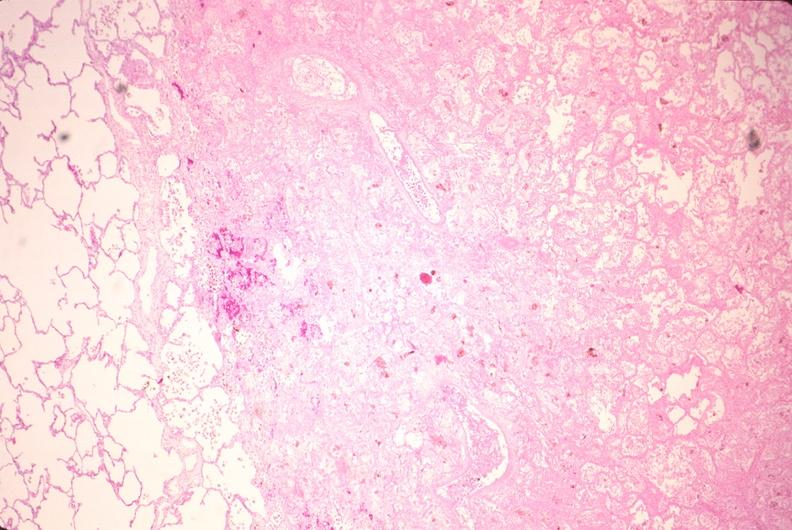does opened muscle show lung, infarct, acute and organized?
Answer the question using a single word or phrase. No 